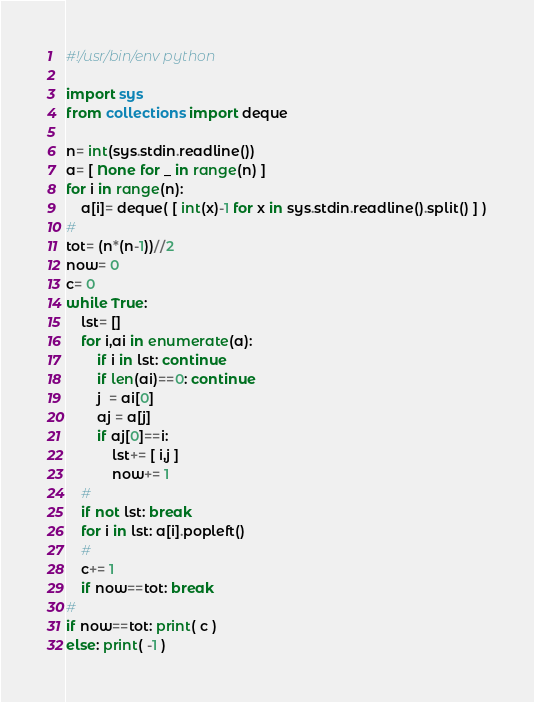Convert code to text. <code><loc_0><loc_0><loc_500><loc_500><_Python_>#!/usr/bin/env python

import sys
from collections import deque

n= int(sys.stdin.readline())
a= [ None for _ in range(n) ]
for i in range(n):
    a[i]= deque( [ int(x)-1 for x in sys.stdin.readline().split() ] )
#
tot= (n*(n-1))//2
now= 0
c= 0
while True:
    lst= []
    for i,ai in enumerate(a):
        if i in lst: continue
        if len(ai)==0: continue
        j  = ai[0]
        aj = a[j]
        if aj[0]==i:
            lst+= [ i,j ]
            now+= 1
    #
    if not lst: break
    for i in lst: a[i].popleft()
    #
    c+= 1
    if now==tot: break
#
if now==tot: print( c )
else: print( -1 )</code> 